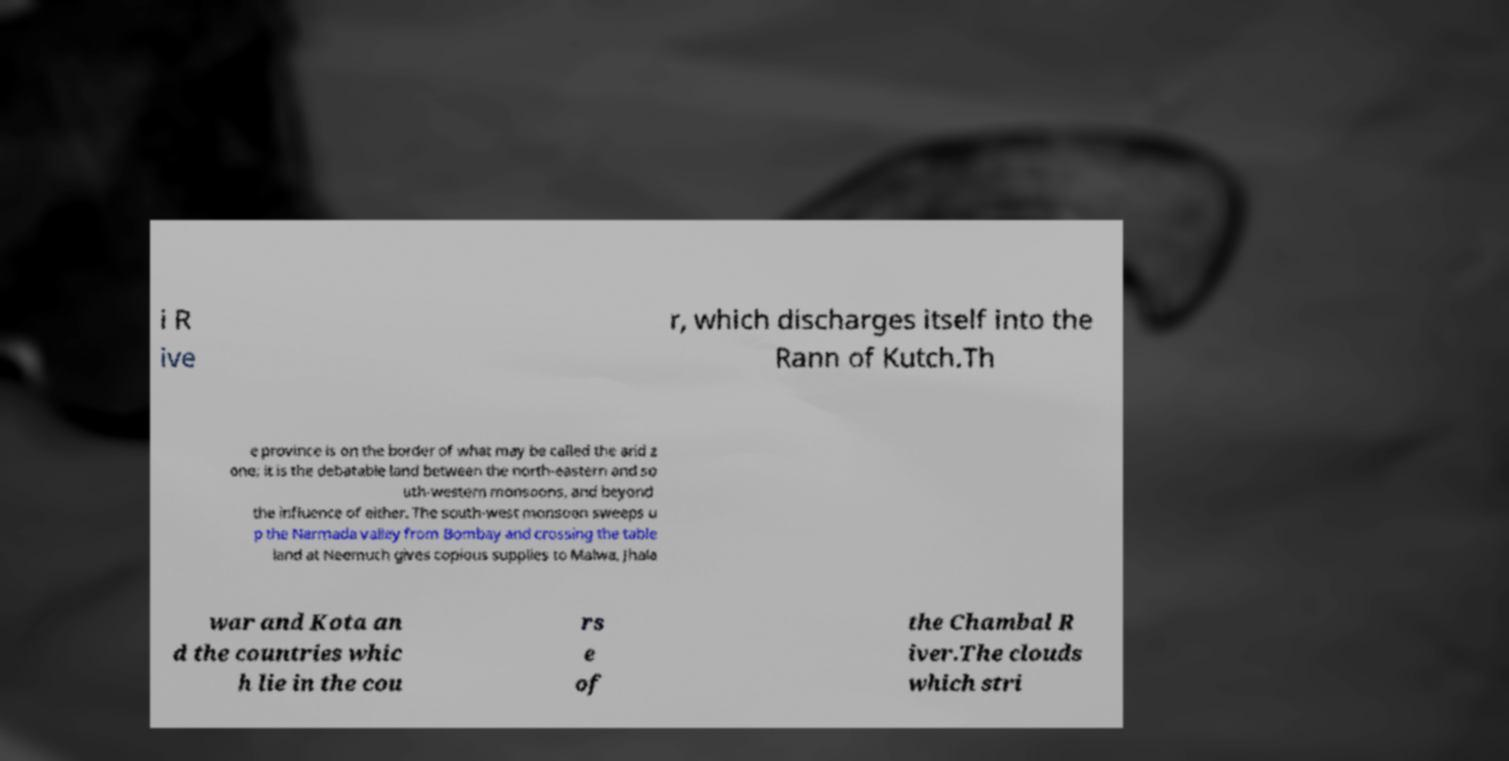Can you read and provide the text displayed in the image?This photo seems to have some interesting text. Can you extract and type it out for me? i R ive r, which discharges itself into the Rann of Kutch.Th e province is on the border of what may be called the arid z one; it is the debatable land between the north-eastern and so uth-western monsoons, and beyond the influence of either. The south-west monsoon sweeps u p the Narmada valley from Bombay and crossing the table land at Neemuch gives copious supplies to Malwa, Jhala war and Kota an d the countries whic h lie in the cou rs e of the Chambal R iver.The clouds which stri 